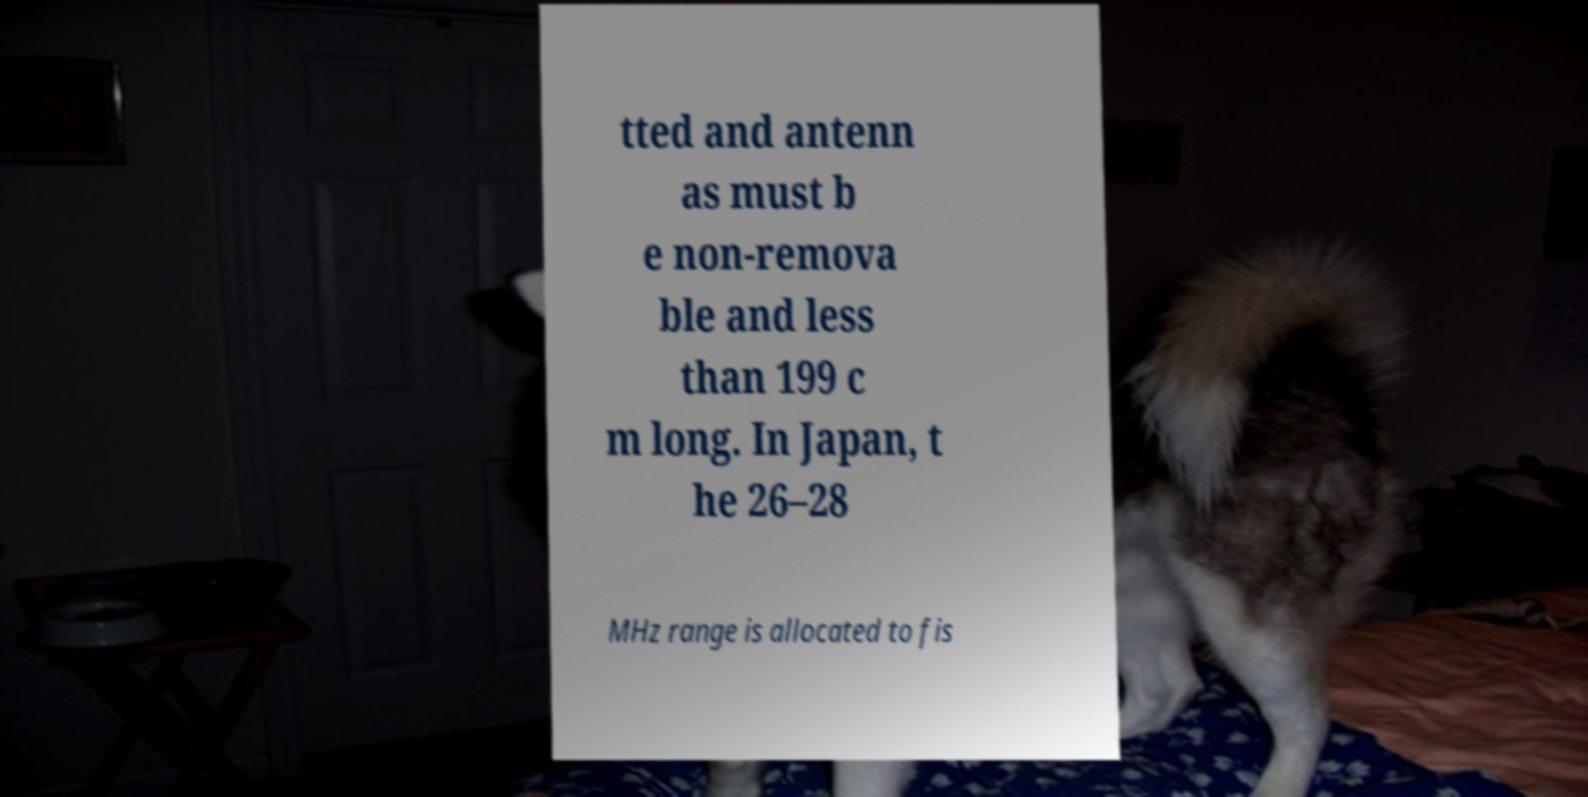Please read and relay the text visible in this image. What does it say? tted and antenn as must b e non-remova ble and less than 199 c m long. In Japan, t he 26–28 MHz range is allocated to fis 